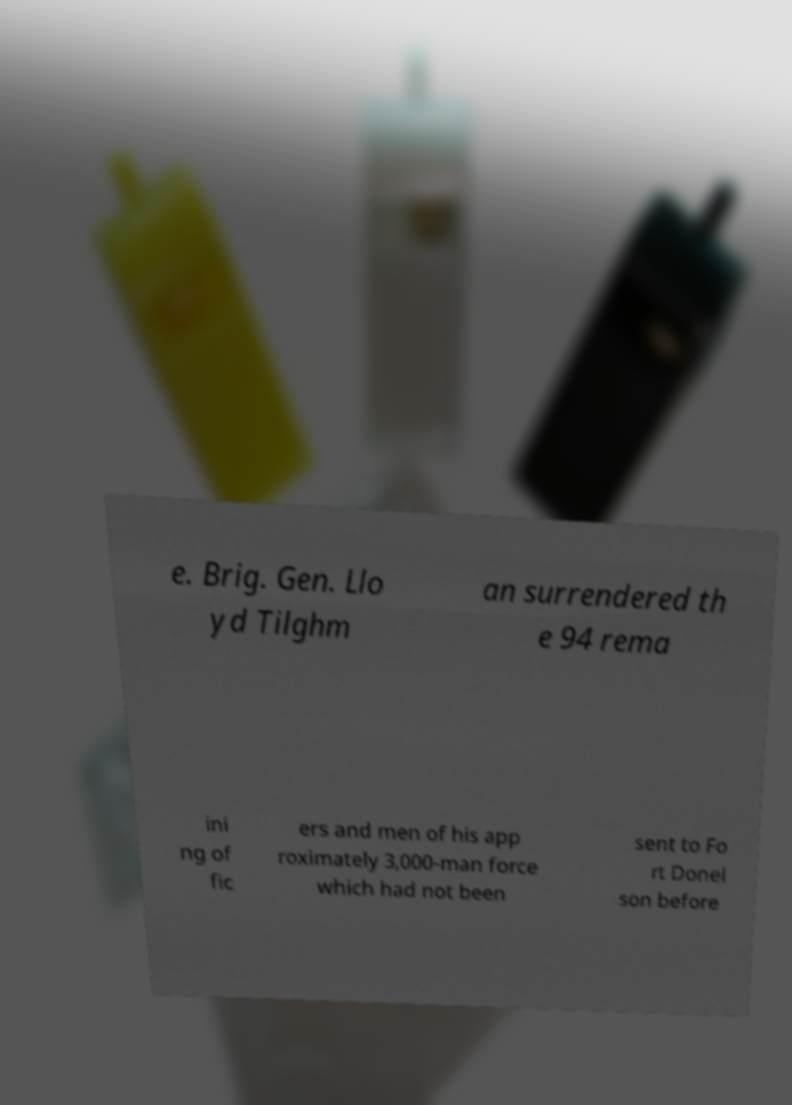Please read and relay the text visible in this image. What does it say? e. Brig. Gen. Llo yd Tilghm an surrendered th e 94 rema ini ng of fic ers and men of his app roximately 3,000-man force which had not been sent to Fo rt Donel son before 